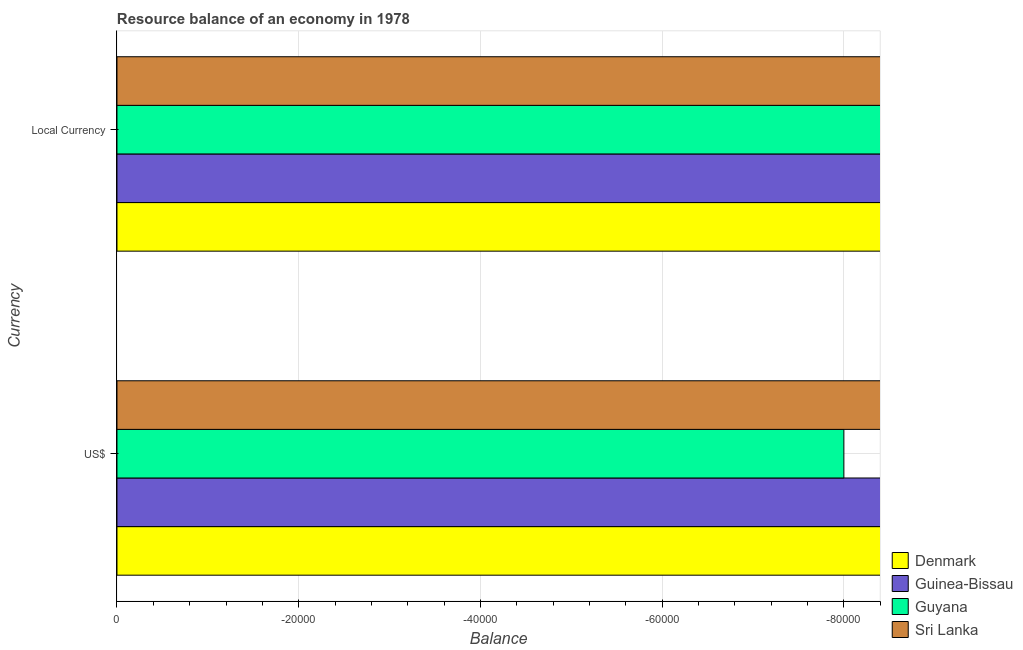How many different coloured bars are there?
Make the answer very short. 0. Are the number of bars per tick equal to the number of legend labels?
Offer a very short reply. No. What is the label of the 1st group of bars from the top?
Offer a terse response. Local Currency. Across all countries, what is the minimum resource balance in us$?
Give a very brief answer. 0. What is the difference between the resource balance in constant us$ in Guyana and the resource balance in us$ in Sri Lanka?
Offer a very short reply. 0. What is the average resource balance in us$ per country?
Ensure brevity in your answer.  0. In how many countries, is the resource balance in us$ greater than -64000 units?
Keep it short and to the point. 0. In how many countries, is the resource balance in constant us$ greater than the average resource balance in constant us$ taken over all countries?
Provide a succinct answer. 0. How many bars are there?
Offer a terse response. 0. How many countries are there in the graph?
Offer a terse response. 4. Does the graph contain any zero values?
Keep it short and to the point. Yes. Where does the legend appear in the graph?
Give a very brief answer. Bottom right. How many legend labels are there?
Give a very brief answer. 4. How are the legend labels stacked?
Provide a succinct answer. Vertical. What is the title of the graph?
Make the answer very short. Resource balance of an economy in 1978. What is the label or title of the X-axis?
Ensure brevity in your answer.  Balance. What is the label or title of the Y-axis?
Provide a short and direct response. Currency. What is the Balance of Denmark in US$?
Provide a succinct answer. 0. What is the Balance of Guyana in US$?
Make the answer very short. 0. What is the Balance of Denmark in Local Currency?
Offer a very short reply. 0. What is the Balance in Guinea-Bissau in Local Currency?
Offer a terse response. 0. What is the Balance in Guyana in Local Currency?
Offer a terse response. 0. What is the total Balance in Guinea-Bissau in the graph?
Keep it short and to the point. 0. What is the total Balance in Guyana in the graph?
Keep it short and to the point. 0. What is the average Balance of Denmark per Currency?
Make the answer very short. 0. What is the average Balance in Guyana per Currency?
Ensure brevity in your answer.  0. What is the average Balance of Sri Lanka per Currency?
Your answer should be very brief. 0. 